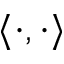Convert formula to latex. <formula><loc_0><loc_0><loc_500><loc_500>\langle \cdot , \cdot \rangle</formula> 